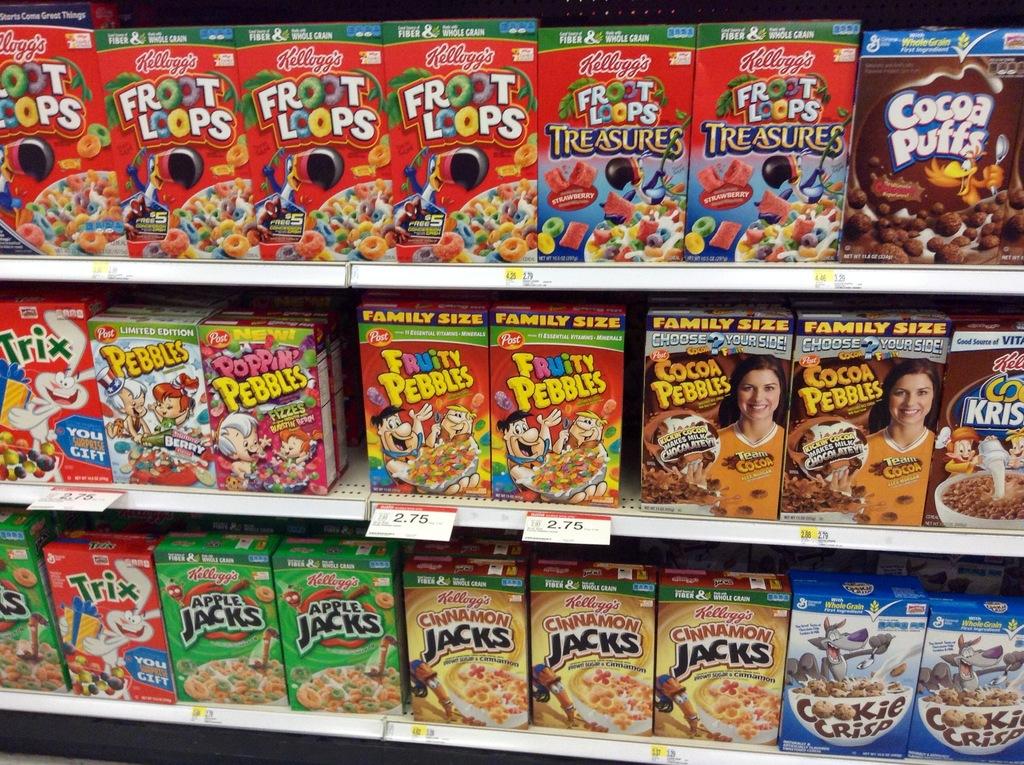What is the name of the brown box cereal on the top shelf?
Your answer should be compact. Cocoa puffs. What is the cereal at the bottom right?
Your answer should be compact. Cookie crisp. 